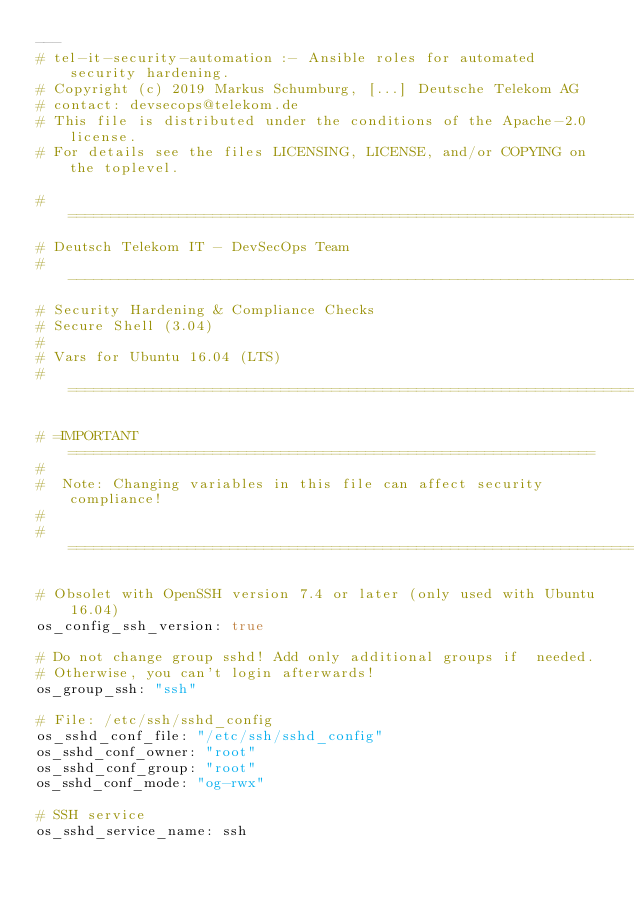<code> <loc_0><loc_0><loc_500><loc_500><_YAML_>---
# tel-it-security-automation :- Ansible roles for automated security hardening.  
# Copyright (c) 2019 Markus Schumburg, [...] Deutsche Telekom AG 
# contact: devsecops@telekom.de 
# This file is distributed under the conditions of the Apache-2.0 license. 
# For details see the files LICENSING, LICENSE, and/or COPYING on the toplevel.

# ========================================================================
# Deutsch Telekom IT - DevSecOps Team
# ------------------------------------------------------------------------
# Security Hardening & Compliance Checks
# Secure Shell (3.04)
#
# Vars for Ubuntu 16.04 (LTS)
# ========================================================================

# =IMPORTANT==============================================================
#
#  Note: Changing variables in this file can affect security compliance!
#
# ========================================================================

# Obsolet with OpenSSH version 7.4 or later (only used with Ubuntu 16.04)
os_config_ssh_version: true

# Do not change group sshd! Add only additional groups if  needed. 
# Otherwise, you can't login afterwards!
os_group_ssh: "ssh"

# File: /etc/ssh/sshd_config
os_sshd_conf_file: "/etc/ssh/sshd_config"
os_sshd_conf_owner: "root"
os_sshd_conf_group: "root"
os_sshd_conf_mode: "og-rwx"

# SSH service
os_sshd_service_name: ssh</code> 